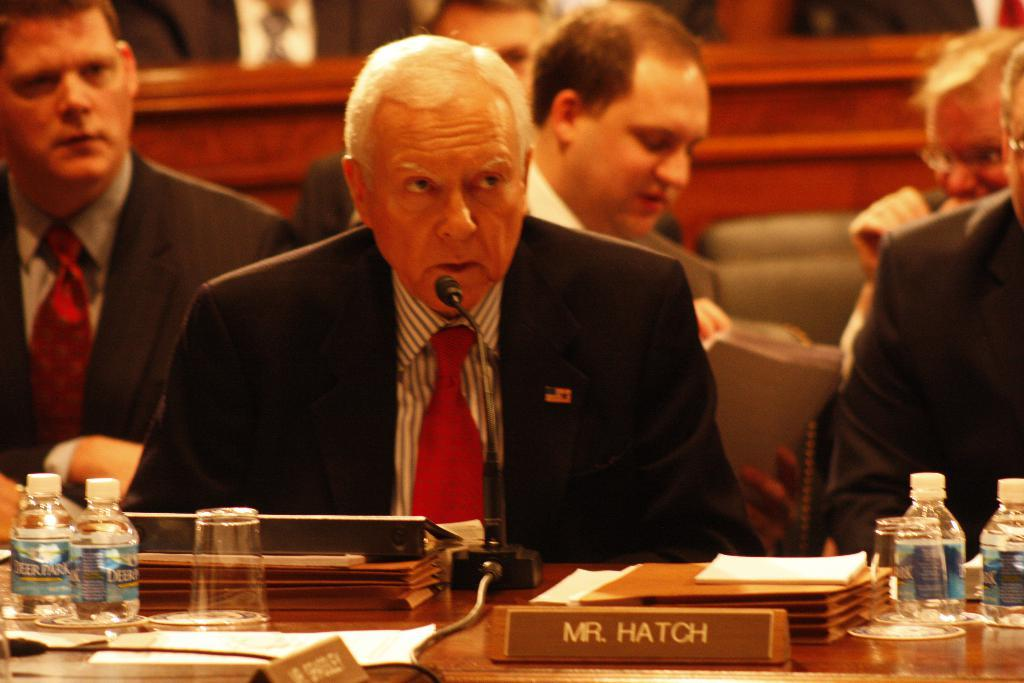What are the people in the image doing? The people in the image are sitting on chairs. Can you identify any specific individuals in the image? Yes, there is a man among the people. What is the man in the image using? The man is using a microphone with a stand in front of him. What is on the table in the image? There is a name plate, a bottle, files, and a glass on the table. Can you tell me how many bees are buzzing around the microphone in the image? There are no bees present in the image; the focus is on the people, the man with the microphone, and the items on the table. 